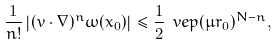Convert formula to latex. <formula><loc_0><loc_0><loc_500><loc_500>\frac { 1 } { n ! } \left | ( v \cdot \nabla ) ^ { n } \omega ( x _ { 0 } ) \right | \leq \frac { 1 } { 2 } \ v e p ( \mu r _ { 0 } ) ^ { N - n } ,</formula> 